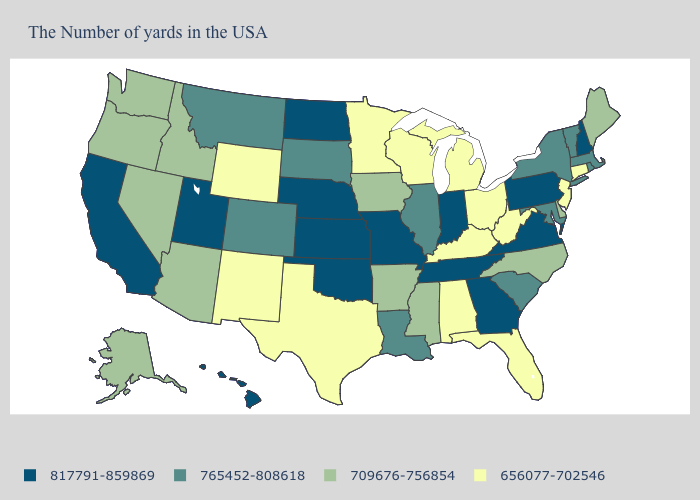How many symbols are there in the legend?
Concise answer only. 4. Does Vermont have the lowest value in the Northeast?
Keep it brief. No. What is the value of Missouri?
Give a very brief answer. 817791-859869. What is the value of North Dakota?
Quick response, please. 817791-859869. What is the value of Kentucky?
Write a very short answer. 656077-702546. What is the value of Rhode Island?
Concise answer only. 765452-808618. Among the states that border Oklahoma , which have the highest value?
Be succinct. Missouri, Kansas. Among the states that border Kentucky , does Virginia have the highest value?
Quick response, please. Yes. How many symbols are there in the legend?
Keep it brief. 4. Does South Dakota have the highest value in the USA?
Give a very brief answer. No. What is the value of Montana?
Be succinct. 765452-808618. Among the states that border South Dakota , which have the highest value?
Give a very brief answer. Nebraska, North Dakota. Does Minnesota have a higher value than New York?
Short answer required. No. Name the states that have a value in the range 817791-859869?
Quick response, please. New Hampshire, Pennsylvania, Virginia, Georgia, Indiana, Tennessee, Missouri, Kansas, Nebraska, Oklahoma, North Dakota, Utah, California, Hawaii. What is the highest value in the Northeast ?
Answer briefly. 817791-859869. 